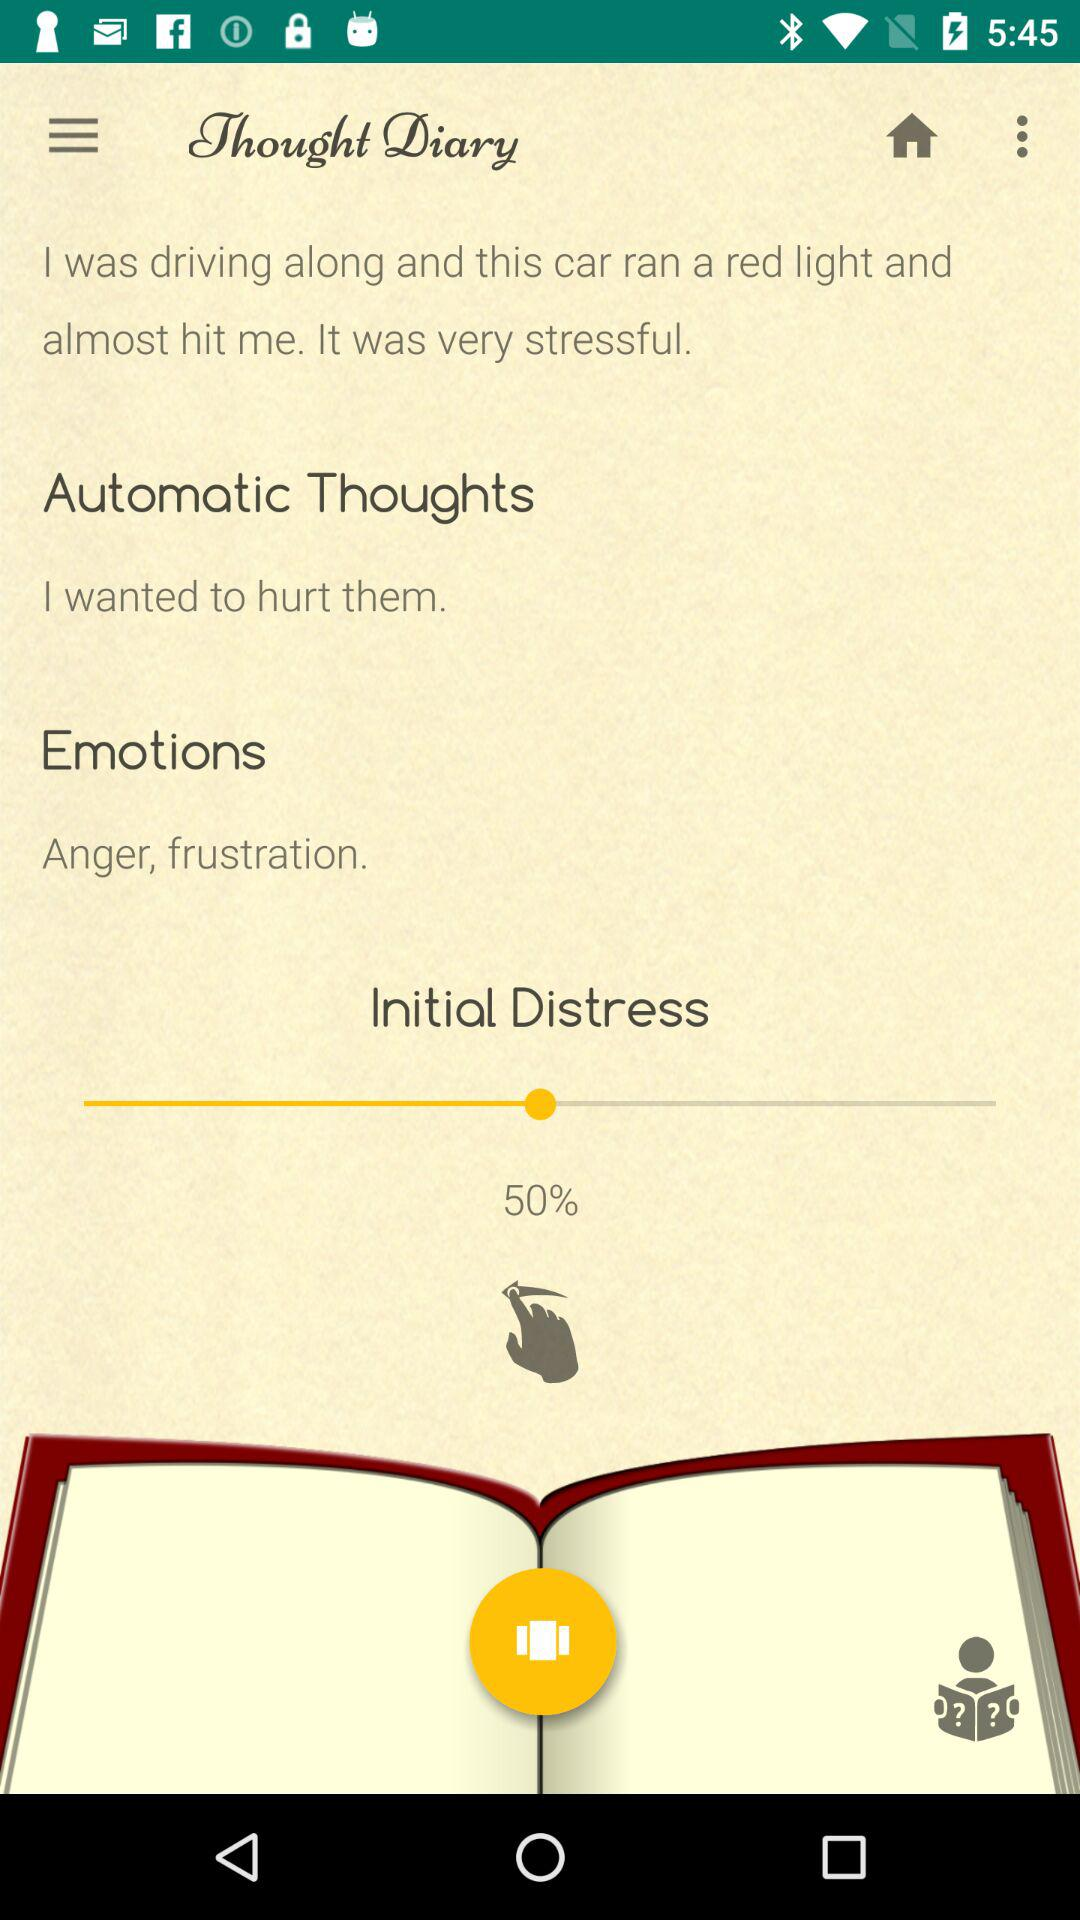What is the automatic thought? The automatic thought is "I wanted to hurt them". 